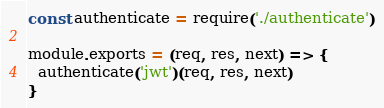<code> <loc_0><loc_0><loc_500><loc_500><_JavaScript_>const authenticate = require('./authenticate')

module.exports = (req, res, next) => {
  authenticate('jwt')(req, res, next)
}
</code> 